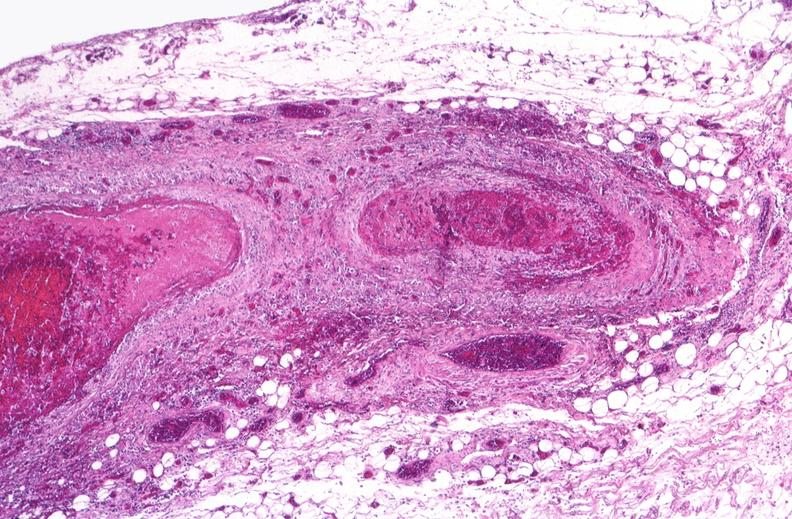s vasculature present?
Answer the question using a single word or phrase. Yes 